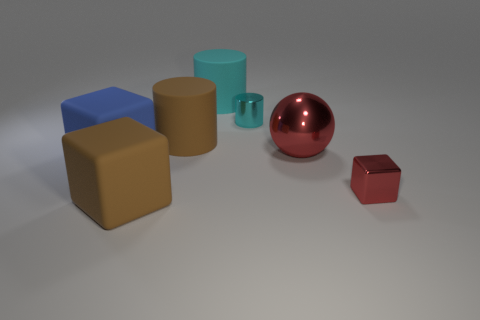Subtract all tiny red metallic cubes. How many cubes are left? 2 Add 2 large cyan metal cubes. How many objects exist? 9 Subtract all brown cubes. How many cubes are left? 2 Subtract all purple cubes. How many cyan cylinders are left? 2 Subtract all big cyan cubes. Subtract all large brown blocks. How many objects are left? 6 Add 7 red metallic objects. How many red metallic objects are left? 9 Add 1 small brown metallic objects. How many small brown metallic objects exist? 1 Subtract 1 brown blocks. How many objects are left? 6 Subtract all balls. How many objects are left? 6 Subtract 1 cylinders. How many cylinders are left? 2 